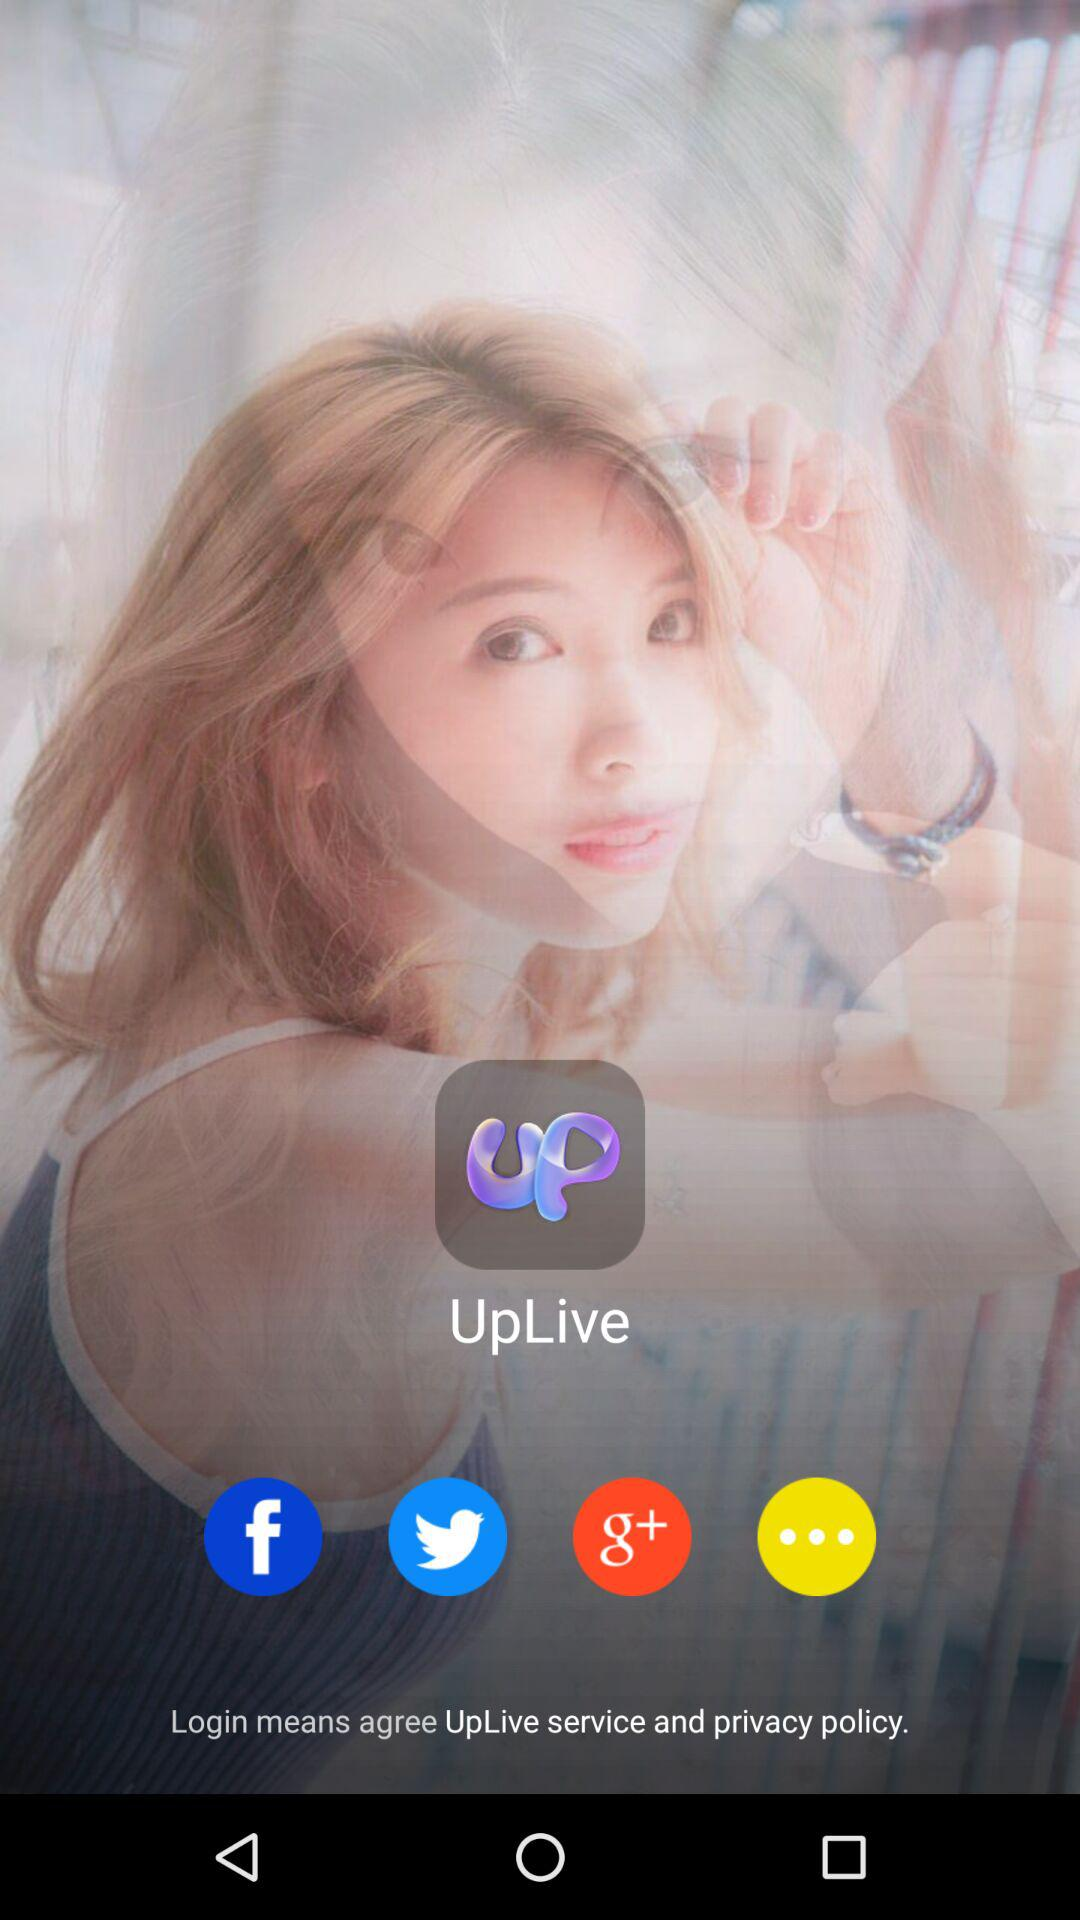What accounts can be used to log in? The accounts that can be used to log in are "Facebook", "Twitter" and "Google+". 